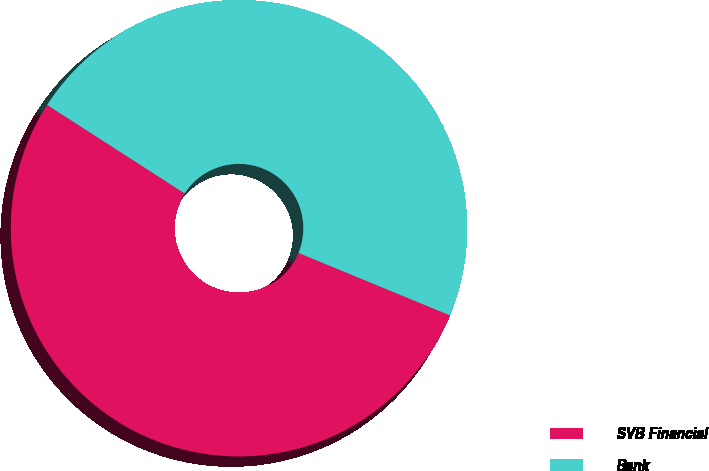Convert chart to OTSL. <chart><loc_0><loc_0><loc_500><loc_500><pie_chart><fcel>SVB Financial<fcel>Bank<nl><fcel>52.88%<fcel>47.12%<nl></chart> 